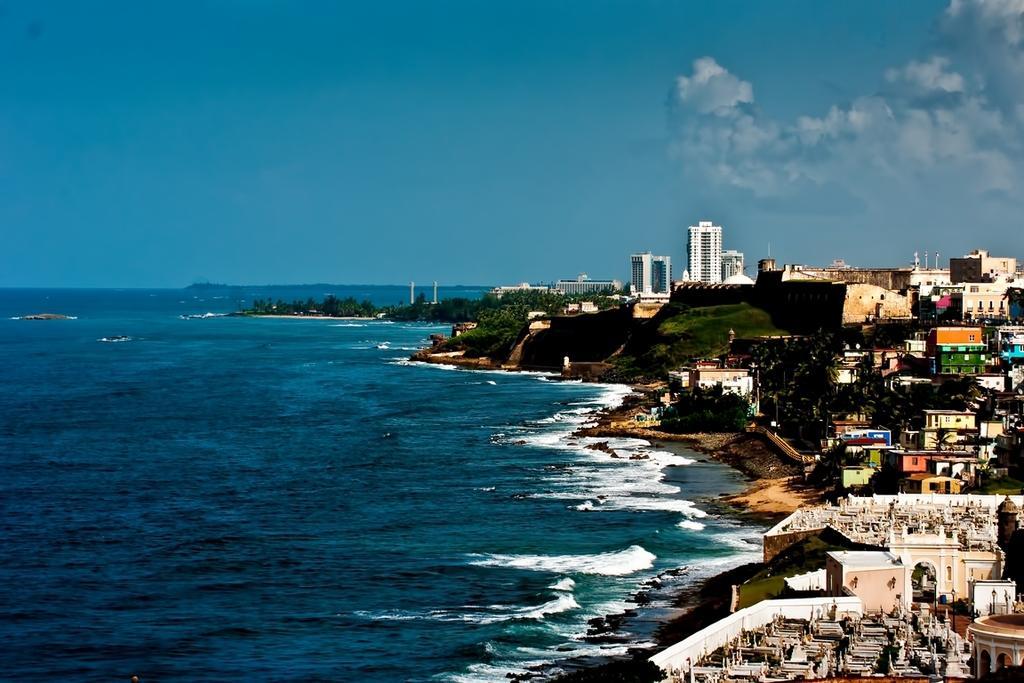How would you summarize this image in a sentence or two? In this picture we can see buildings with windows, trees, water, grass and in the background we can see the sky with clouds. 